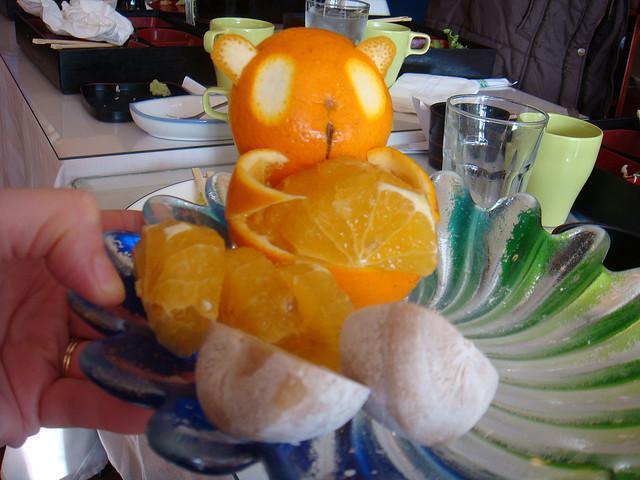How many bowls are in the picture?
Give a very brief answer. 2. How many oranges are in the picture?
Give a very brief answer. 6. How many cups are in the photo?
Give a very brief answer. 3. How many giraffes are in this picture?
Give a very brief answer. 0. 